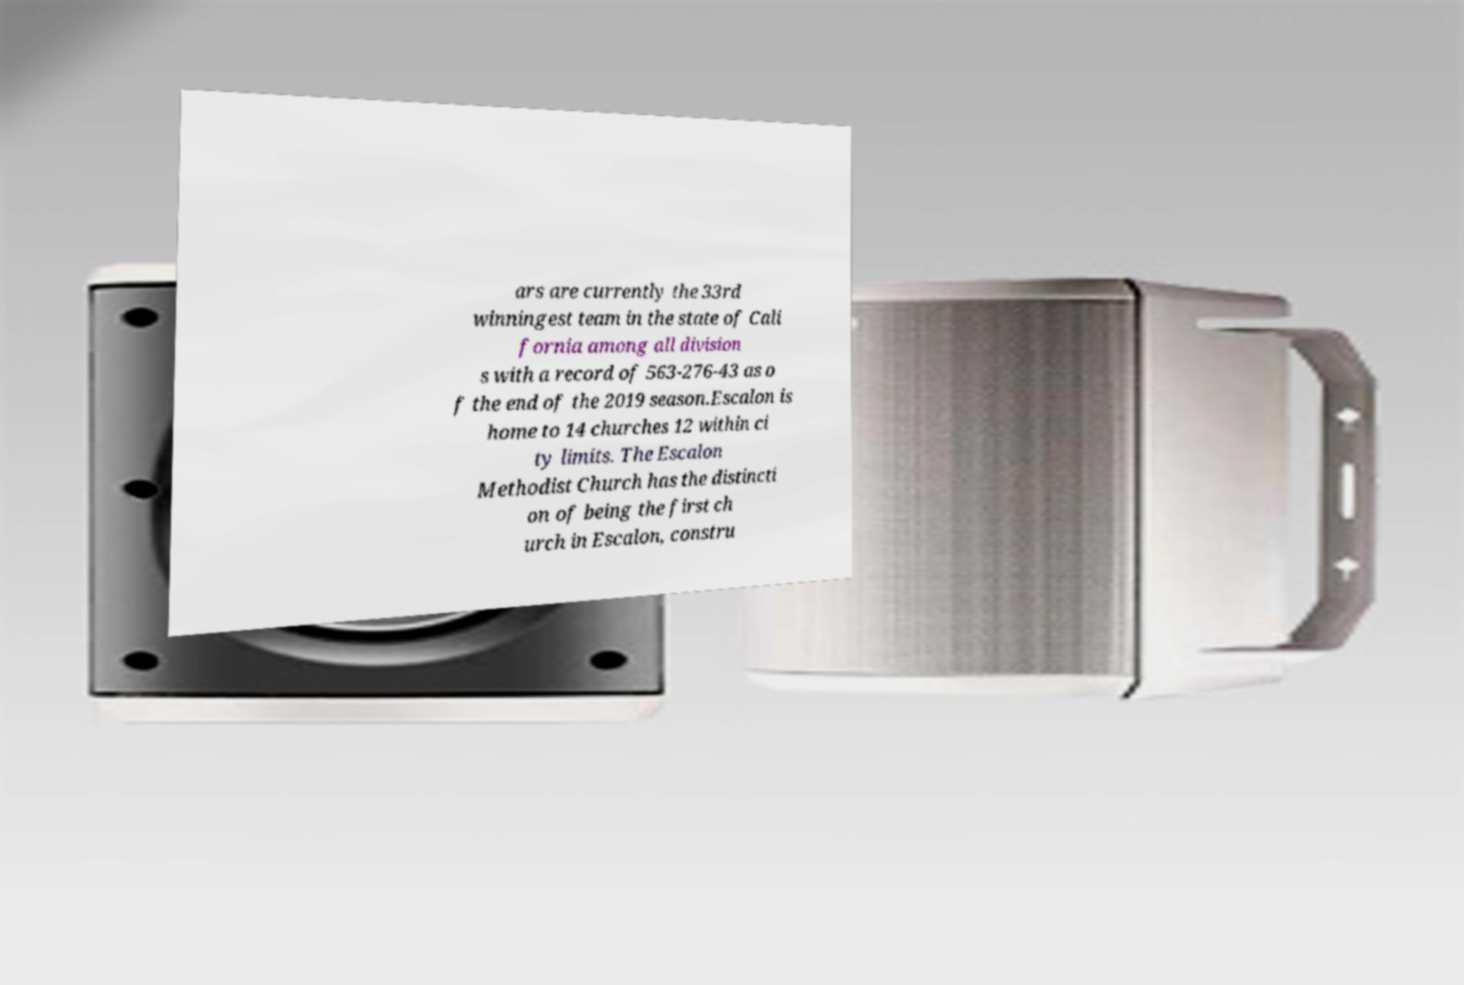Can you accurately transcribe the text from the provided image for me? ars are currently the 33rd winningest team in the state of Cali fornia among all division s with a record of 563-276-43 as o f the end of the 2019 season.Escalon is home to 14 churches 12 within ci ty limits. The Escalon Methodist Church has the distincti on of being the first ch urch in Escalon, constru 